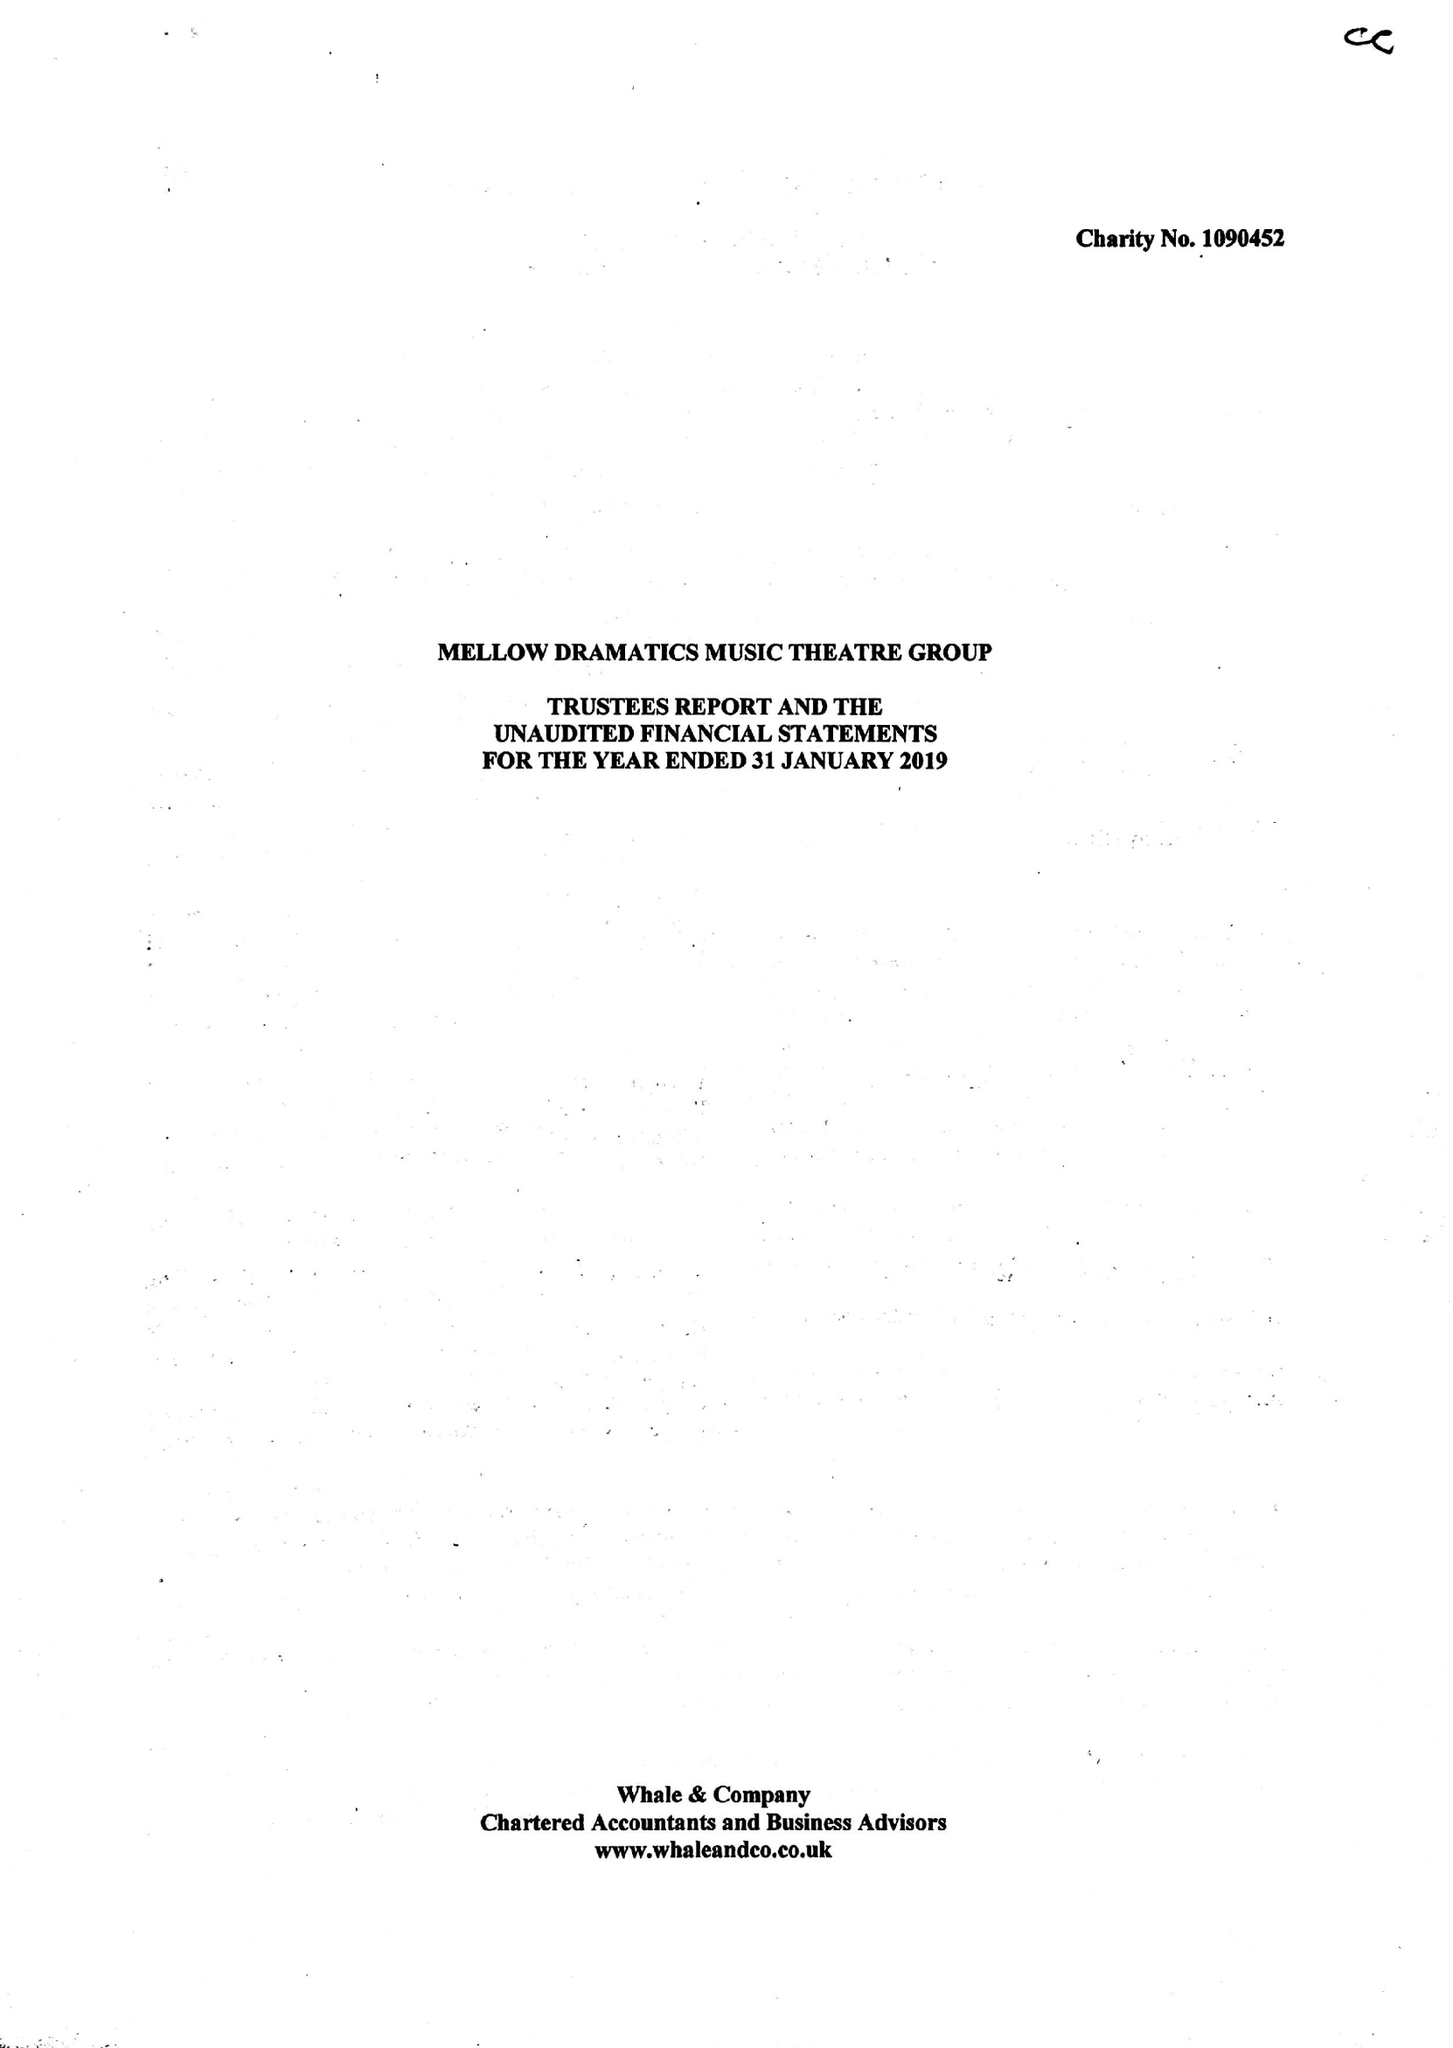What is the value for the report_date?
Answer the question using a single word or phrase. 2019-01-31 